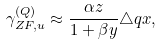<formula> <loc_0><loc_0><loc_500><loc_500>\gamma _ { Z F , u } ^ { ( Q ) } \approx \frac { \alpha { z } } { 1 + \beta y } \triangle q { x } ,</formula> 